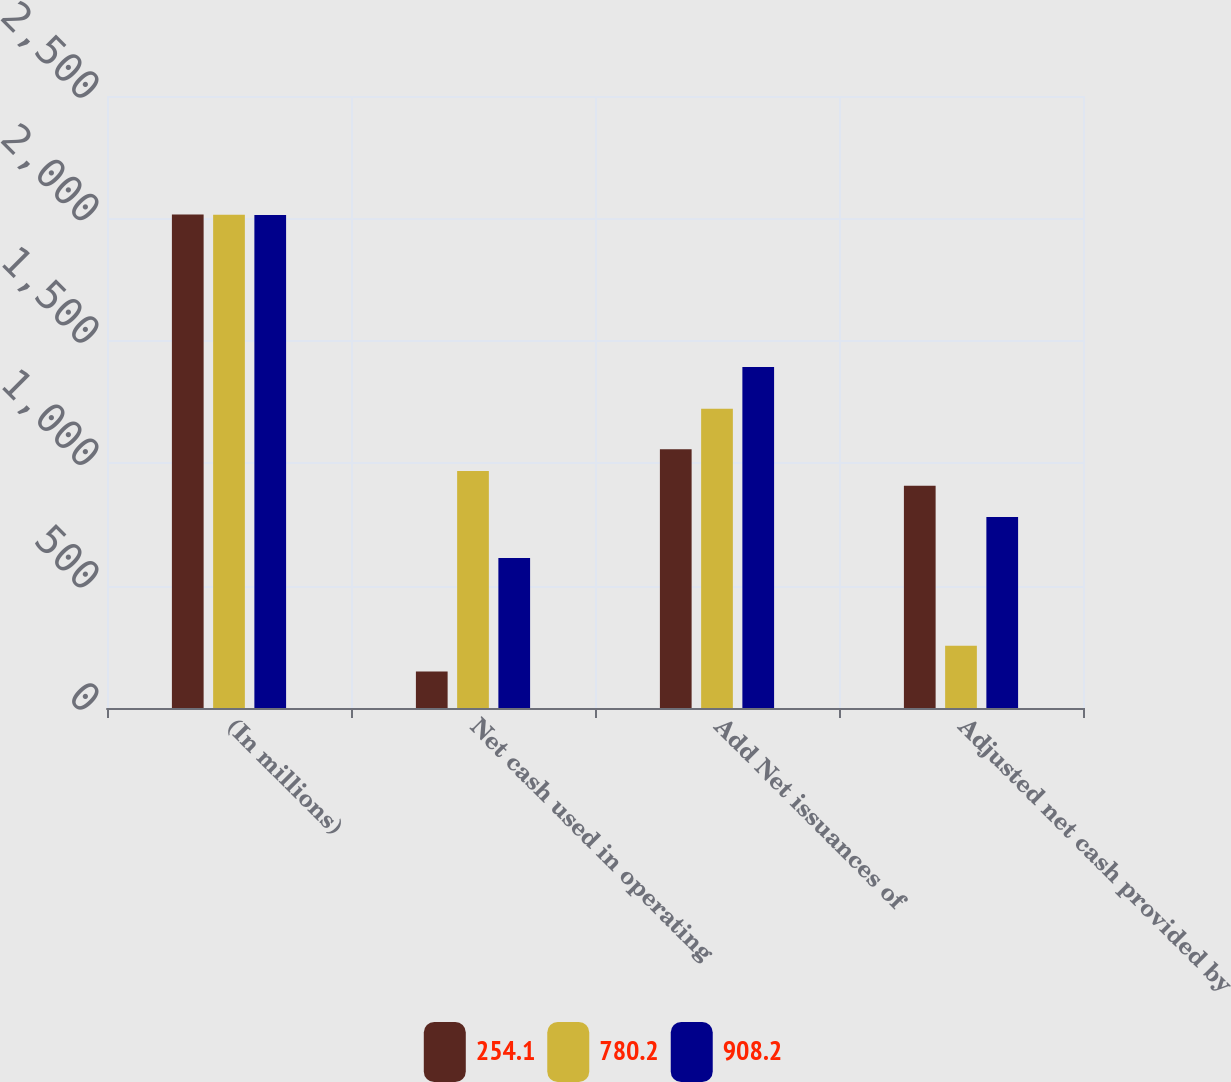Convert chart to OTSL. <chart><loc_0><loc_0><loc_500><loc_500><stacked_bar_chart><ecel><fcel>(In millions)<fcel>Net cash used in operating<fcel>Add Net issuances of<fcel>Adjusted net cash provided by<nl><fcel>254.1<fcel>2016<fcel>148.9<fcel>1057.1<fcel>908.2<nl><fcel>780.2<fcel>2015<fcel>968.1<fcel>1222.2<fcel>254.1<nl><fcel>908.2<fcel>2014<fcel>613.2<fcel>1393.4<fcel>780.2<nl></chart> 